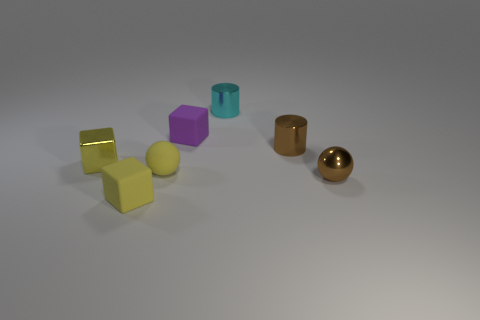Add 1 shiny things. How many objects exist? 8 Subtract all blocks. How many objects are left? 4 Add 2 balls. How many balls are left? 4 Add 2 small cyan things. How many small cyan things exist? 3 Subtract 0 gray cubes. How many objects are left? 7 Subtract all purple cubes. Subtract all tiny cyan rubber things. How many objects are left? 6 